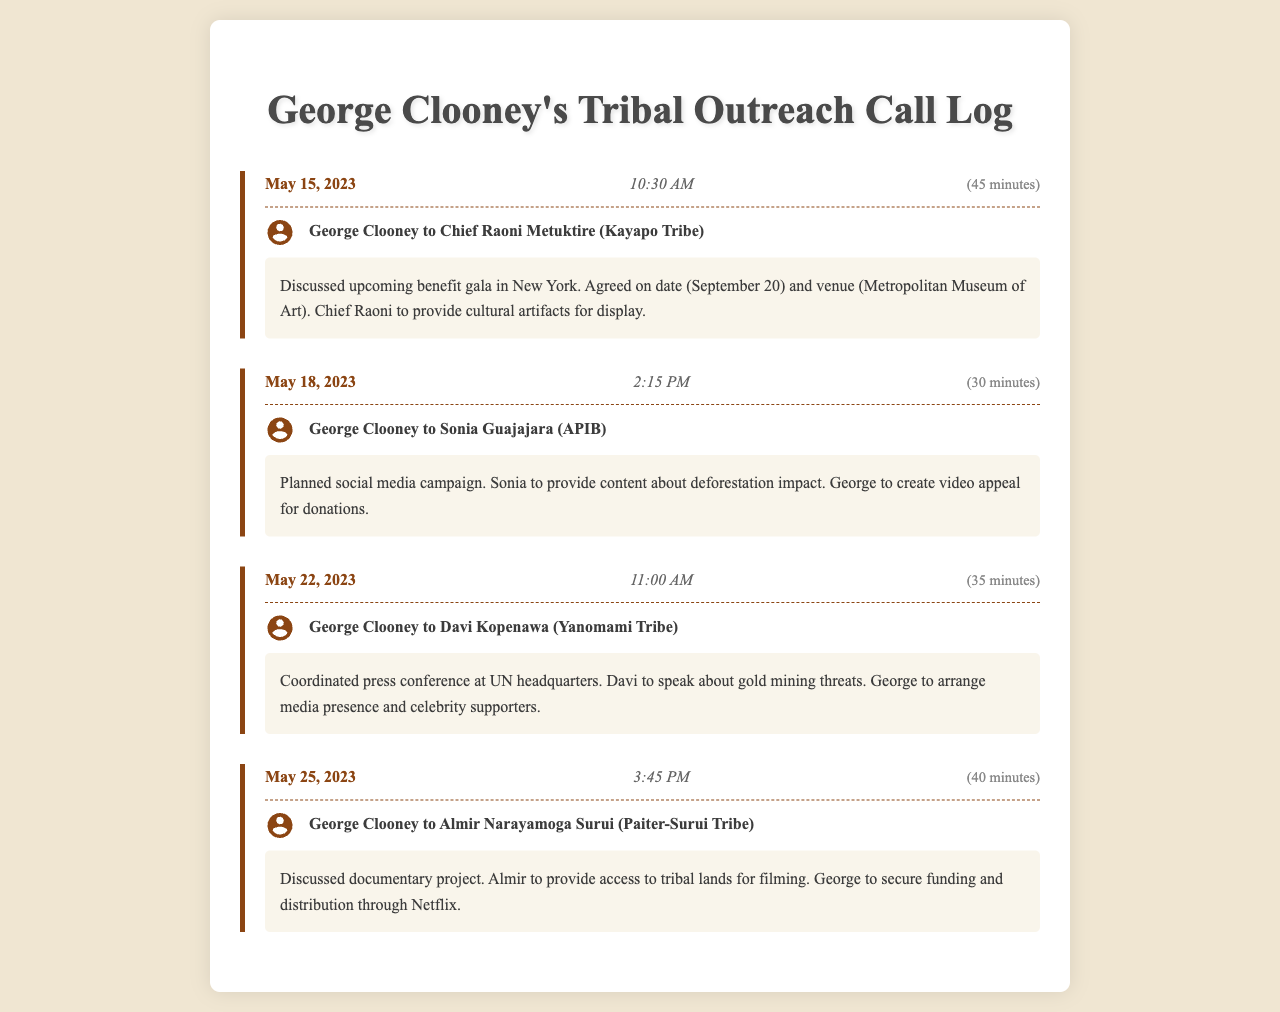What was the date of the first call? The first call took place on May 15, 2023, as shown in the call log.
Answer: May 15, 2023 Who did George Clooney speak to on May 18, 2023? The call details indicate that he spoke to Sonia Guajajara from APIB on this date.
Answer: Sonia Guajajara How long was the call with Chief Raoni Metuktire? The call duration is explicitly stated as 45 minutes.
Answer: 45 minutes What event is being planned for September 20, 2023? The call summary mentions a benefit gala set for this date.
Answer: Benefit gala Which tribe did Davi Kopenawa represent in the May 22, 2023 call? Davi Kopenawa is identified as a representative of the Yanomami Tribe in the call log.
Answer: Yanomami Tribe What was discussed in the May 25, 2023 call? The call summary indicates a discussion about a documentary project.
Answer: Documentary project How many calls occurred in May 2023? By counting the entries in the log, there were four calls documented in May 2023.
Answer: Four What venue was agreed upon for the gala? The call discusses the venue as the Metropolitan Museum of Art for the gala.
Answer: Metropolitan Museum of Art What type of campaign was planned during the May 18, 2023 call? It mentions a social media campaign in connection with fundraising.
Answer: Social media campaign 